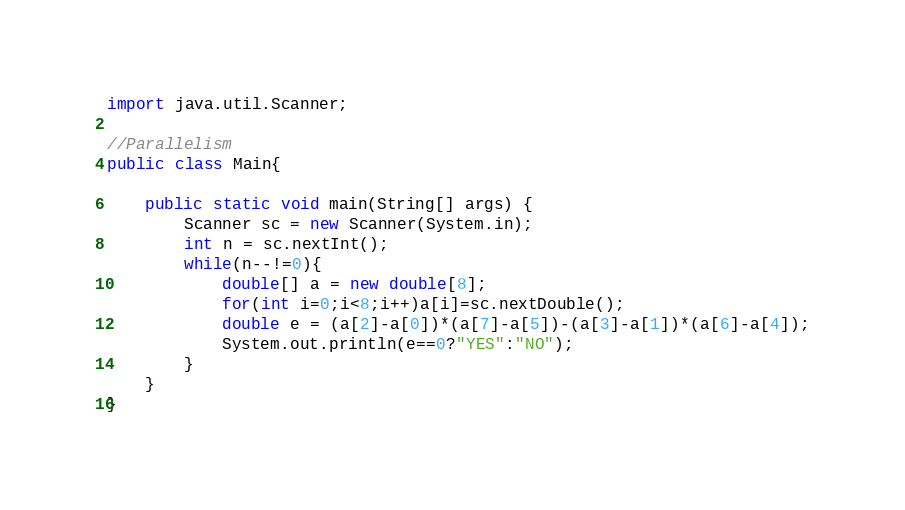Convert code to text. <code><loc_0><loc_0><loc_500><loc_500><_Java_>import java.util.Scanner;
 
//Parallelism
public class Main{
 
    public static void main(String[] args) {
        Scanner sc = new Scanner(System.in);
        int n = sc.nextInt();
        while(n--!=0){
            double[] a = new double[8];
            for(int i=0;i<8;i++)a[i]=sc.nextDouble();
            double e = (a[2]-a[0])*(a[7]-a[5])-(a[3]-a[1])*(a[6]-a[4]);
            System.out.println(e==0?"YES":"NO");
        }
    }
}
</code> 